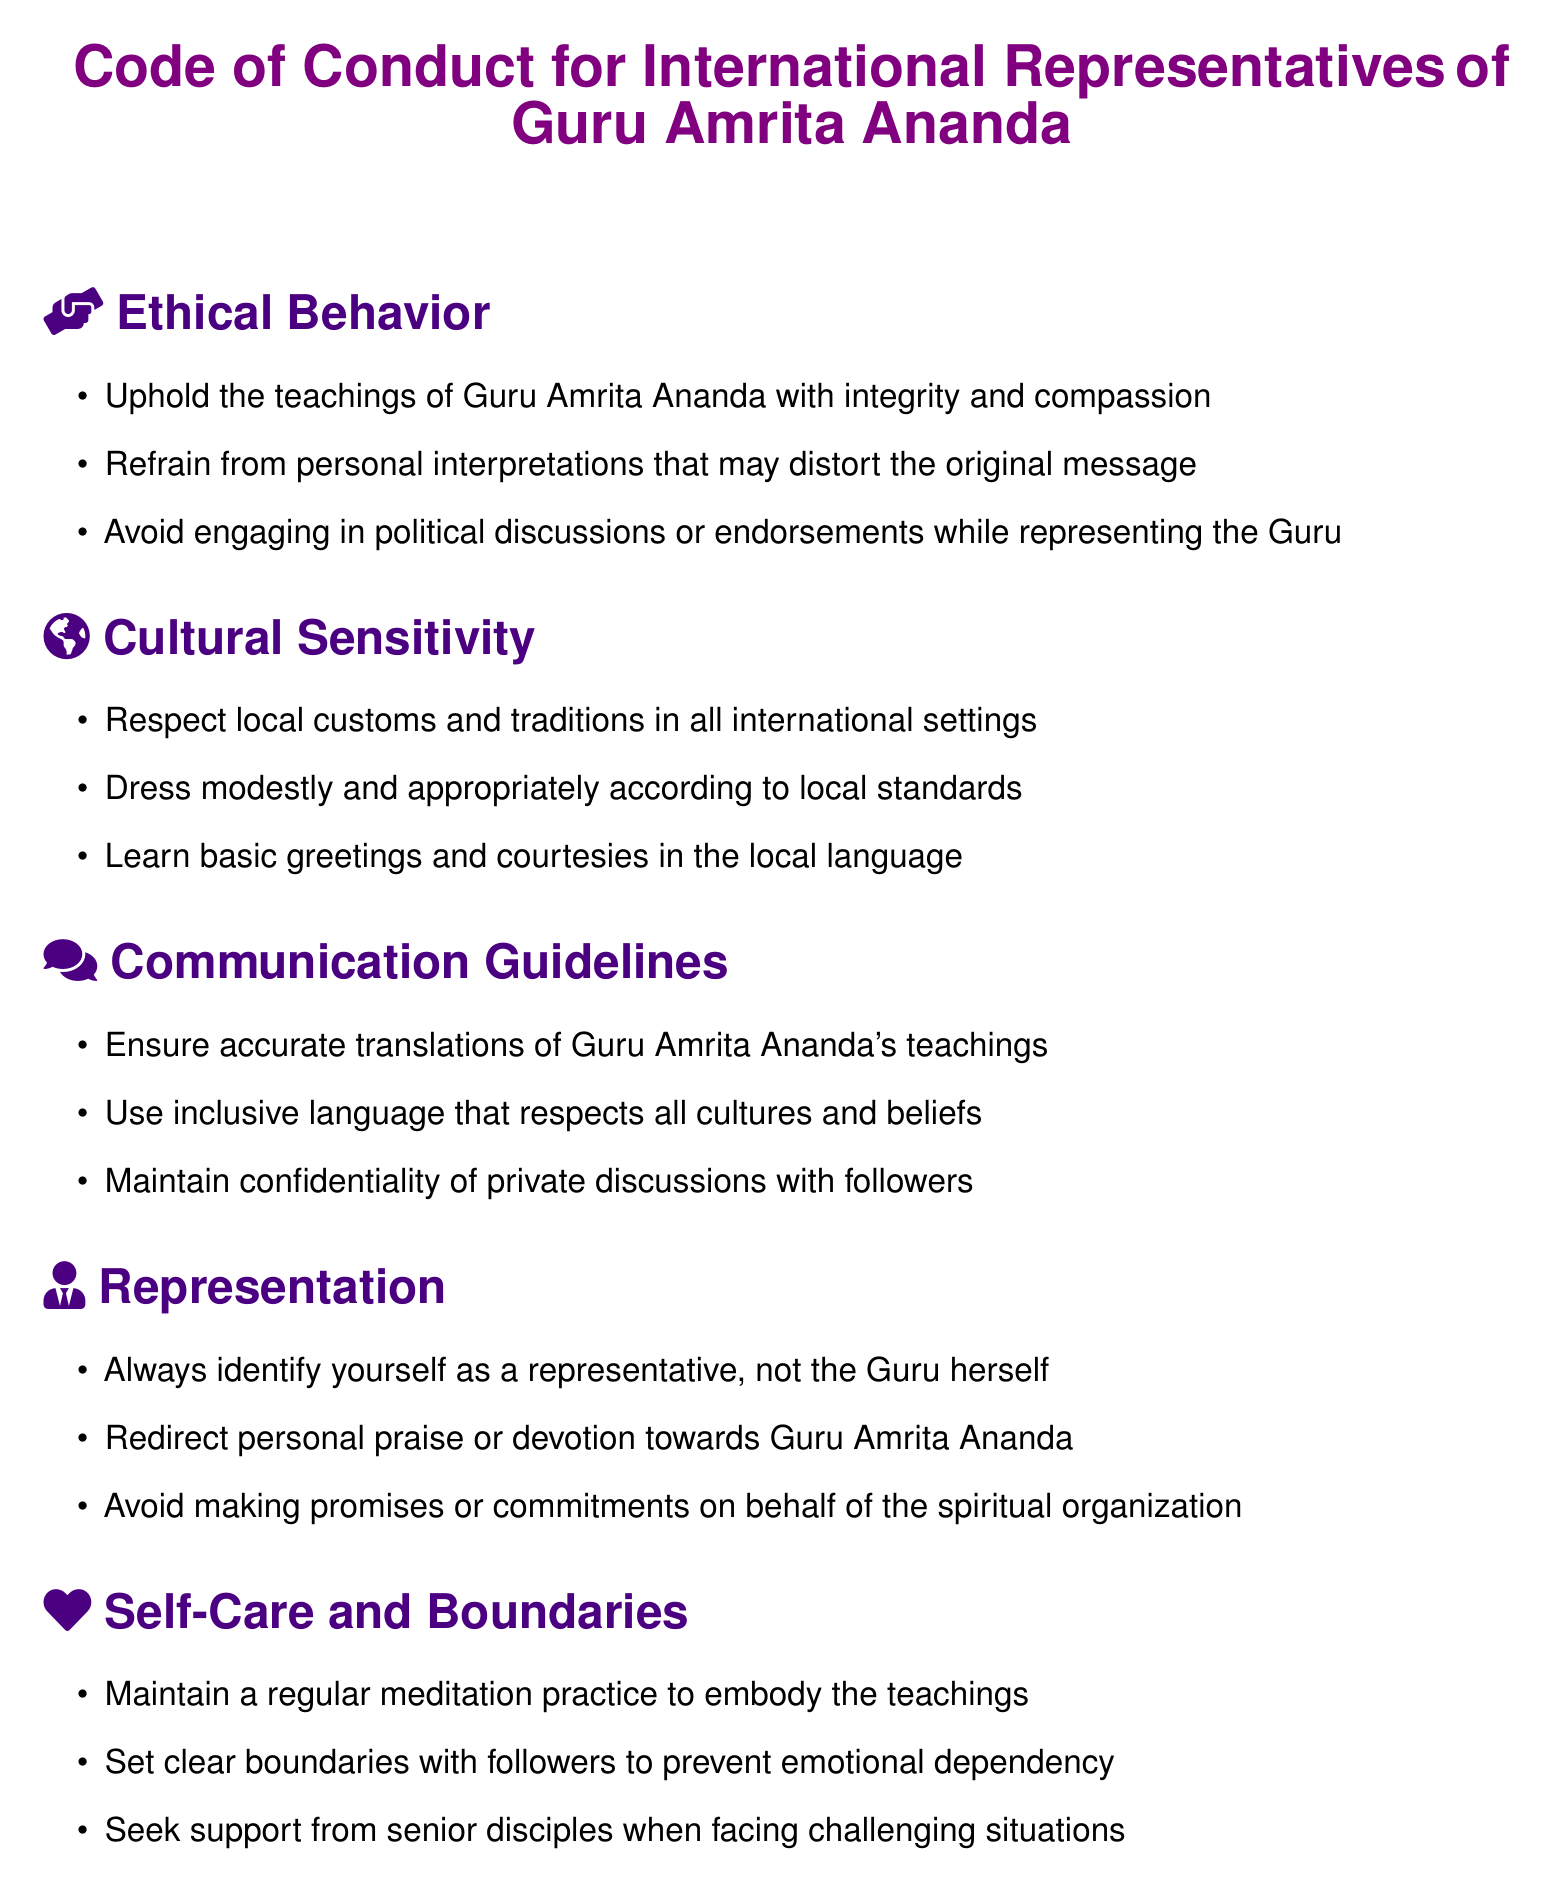What is the title of the document? The title clearly indicates the focus of the document, which is aimed at the representatives of the spiritual leader.
Answer: Code of Conduct for International Representatives Who is the spiritual leader mentioned in the document? The document explicitly states the name of the spiritual leader for whom the code of conduct is intended.
Answer: Guru Amrita Ananda What is one guideline under Ethical Behavior? The guideline specifies how representatives should align their behavior with the teachings of the spiritual leader.
Answer: Uphold the teachings of Guru Amrita Ananda with integrity and compassion What should representatives respect according to the Cultural Sensitivity section? This section emphasizes the importance of understanding and honoring different cultures during international engagements.
Answer: Local customs and traditions What is a key aspect of the Representation section? This section highlights how representatives should position themselves in relation to the spiritual leader to avoid misinterpretation.
Answer: Always identify yourself as a representative, not the Guru herself What is mentioned as a self-care practice in the document? This detail reflects the importance of personal well-being for those representing the spiritual leader.
Answer: Regular meditation practice 